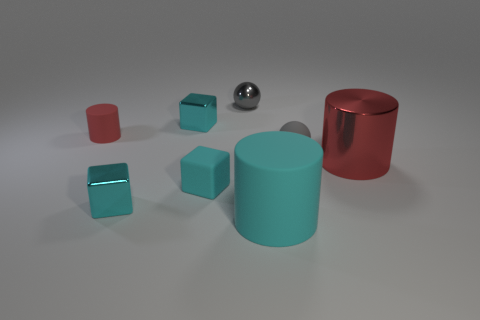Add 2 cubes. How many objects exist? 10 Subtract all spheres. How many objects are left? 6 Add 4 small matte things. How many small matte things exist? 7 Subtract 0 purple spheres. How many objects are left? 8 Subtract all small red objects. Subtract all big matte objects. How many objects are left? 6 Add 3 small cylinders. How many small cylinders are left? 4 